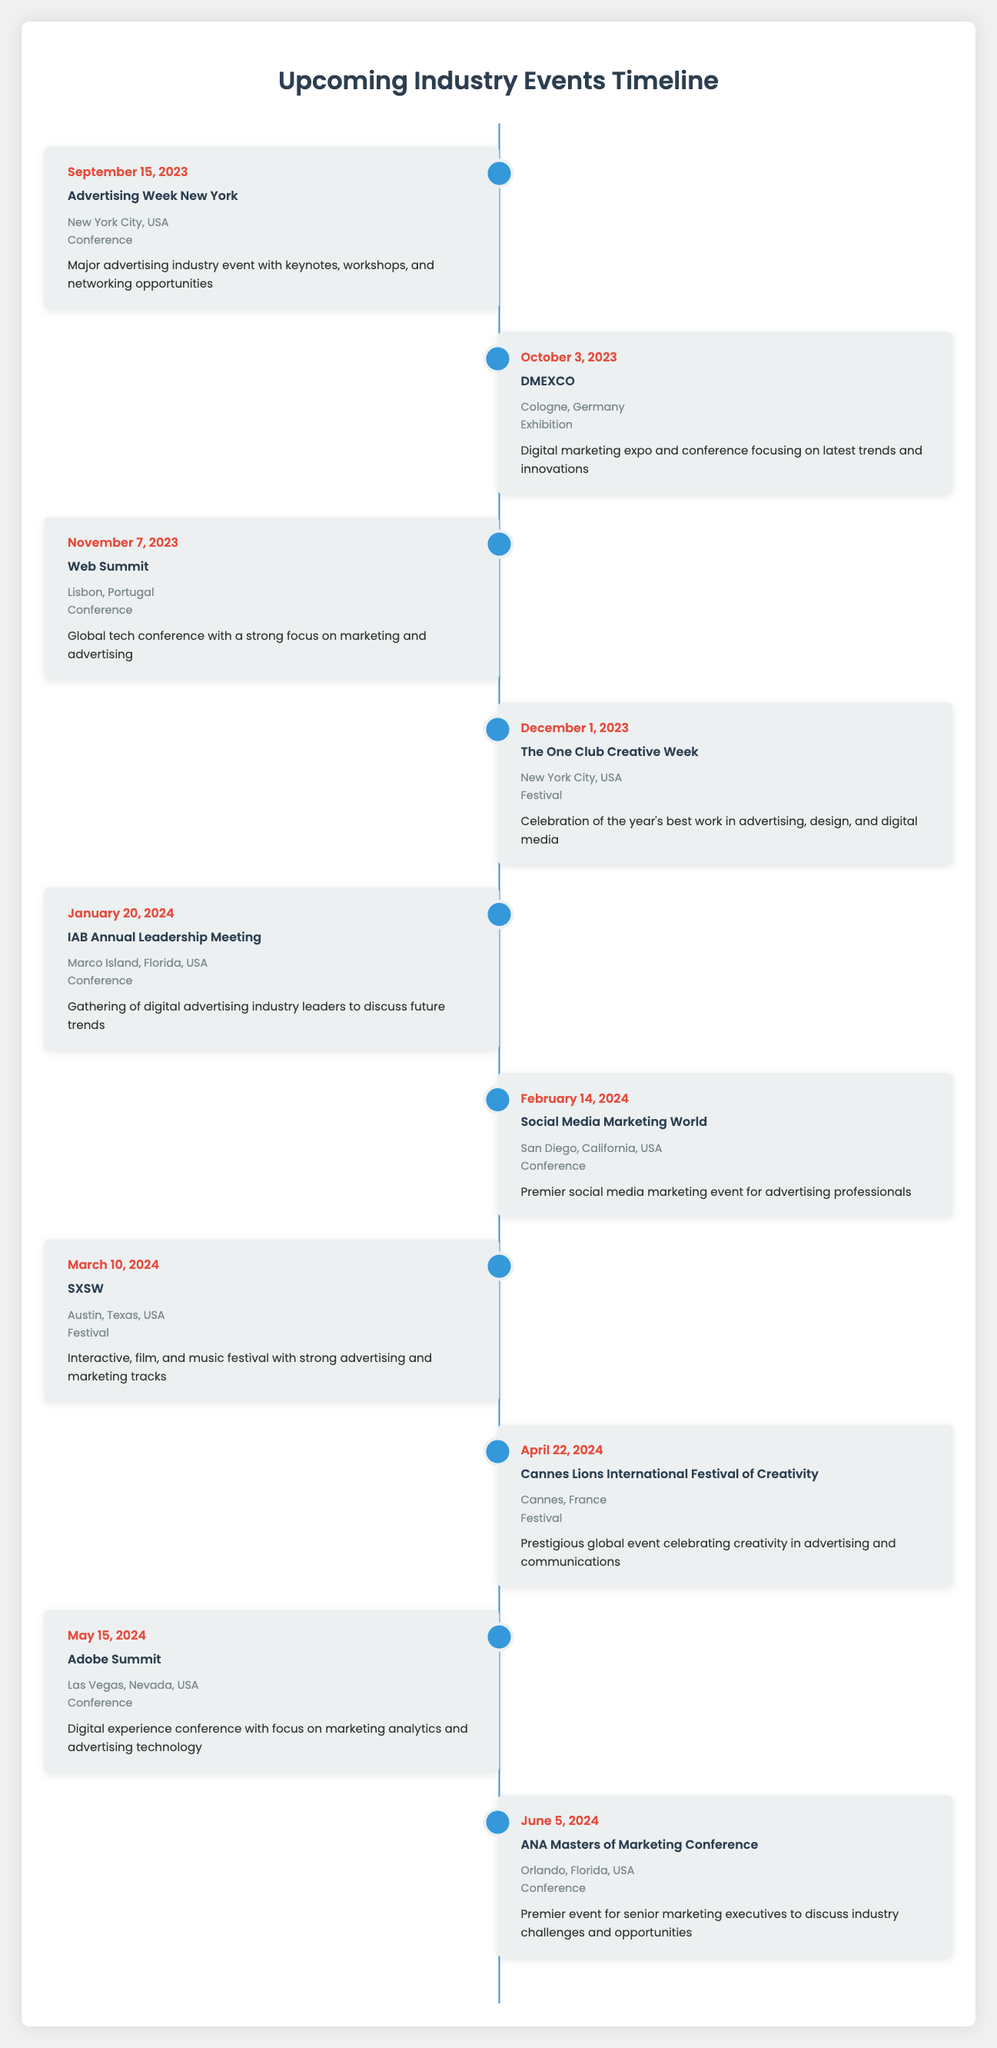What is the date of the Advertising Week New York event? The date for the Advertising Week New York event is clearly listed in the table as September 15, 2023.
Answer: September 15, 2023 How many conferences are scheduled before the end of 2023? There are four conferences listed before the end of 2023: Advertising Week New York, DMEXCO, Web Summit, and The One Club Creative Week. Therefore, the count of conferences is 4.
Answer: 4 Is the Social Media Marketing World event taking place in February? The table indicates that Social Media Marketing World is scheduled for February 14, 2024, confirming that it is indeed in February.
Answer: Yes Which event comes after the IAB Annual Leadership Meeting? The event that follows the IAB Annual Leadership Meeting (on January 20, 2024) is the Social Media Marketing World, which is scheduled for February 14, 2024.
Answer: Social Media Marketing World What is the difference in days between the Web Summit and The One Club Creative Week? The Web Summit is on November 7, 2023, and The One Club Creative Week is on December 1, 2023. The difference is 24 days (from November 7 to December 1).
Answer: 24 days How many festivals are listed in the events? There are three festivals in the events section: The One Club Creative Week, SXSW, and Cannes Lions International Festival of Creativity. Therefore, the total number of festivals is 3.
Answer: 3 Do any events occur in Orlando, Florida, USA? The table shows that the ANA Masters of Marketing Conference is scheduled in Orlando, Florida, USA, which confirms that there is indeed an event in that location.
Answer: Yes What is the type of the Cannes Lions International Festival of Creativity? The type of the Cannes Lions International Festival of Creativity is specified in the table as a festival.
Answer: Festival 